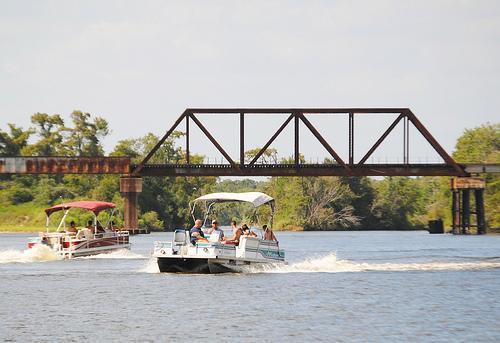How many passengers are in the white boat?
Give a very brief answer. 5. How many boats are in the water?
Give a very brief answer. 2. How many boats are there?
Give a very brief answer. 2. 